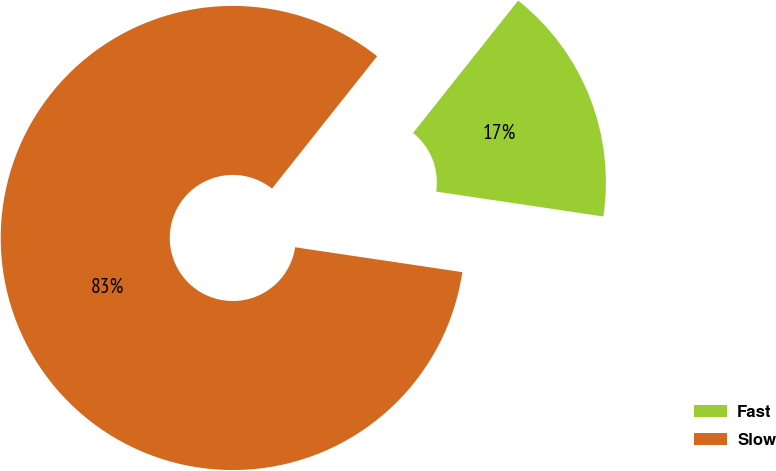Convert chart. <chart><loc_0><loc_0><loc_500><loc_500><pie_chart><fcel>Fast<fcel>Slow<nl><fcel>16.67%<fcel>83.33%<nl></chart> 